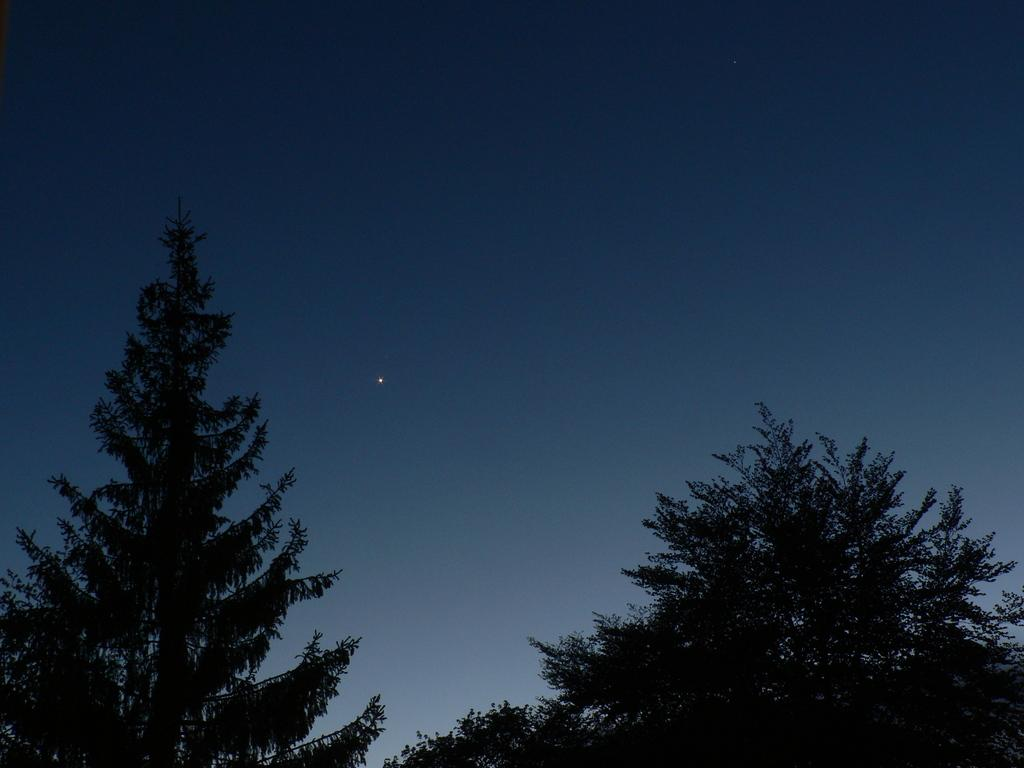What type of vegetation can be seen in the image? There are trees in the image. What is visible in the background of the image? There is a sky visible in the image. Can you describe the celestial object visible in the sky? There is a star visible in the sky. What type of lettuce is being used to make a salad in the image? There is no lettuce or salad present in the image; it features trees and a star in the sky. What is the interest rate on the loan in the image? There is no loan or financial information present in the image. 